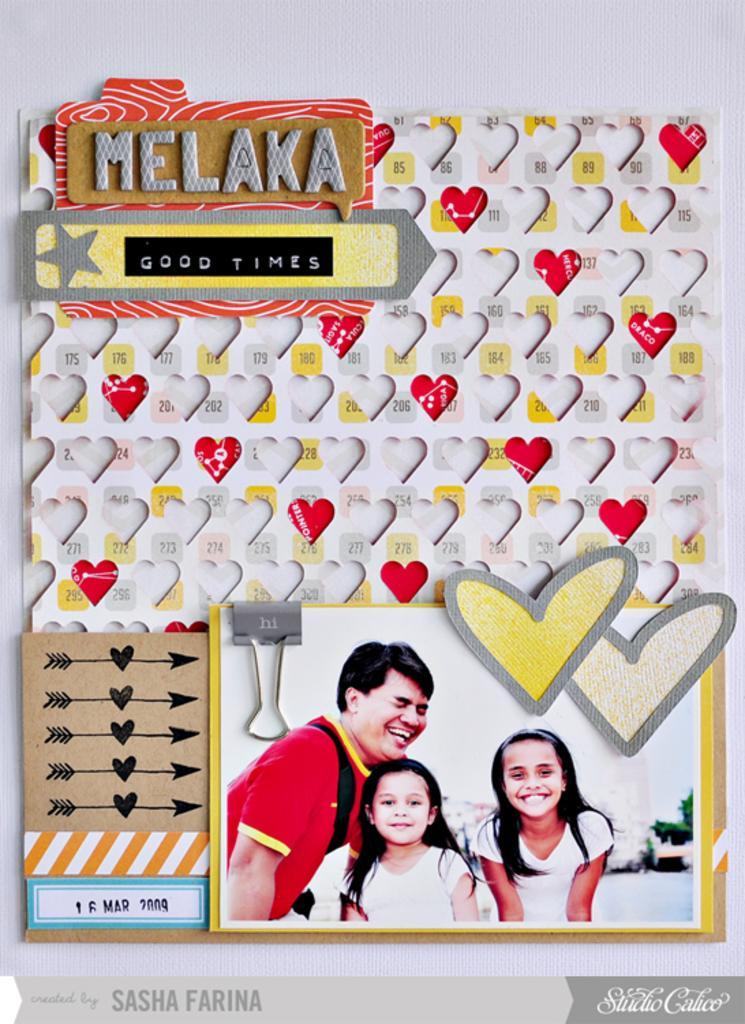Can you describe this image briefly? In this picture we can see a poster in which we can see few people images along with symbols. 